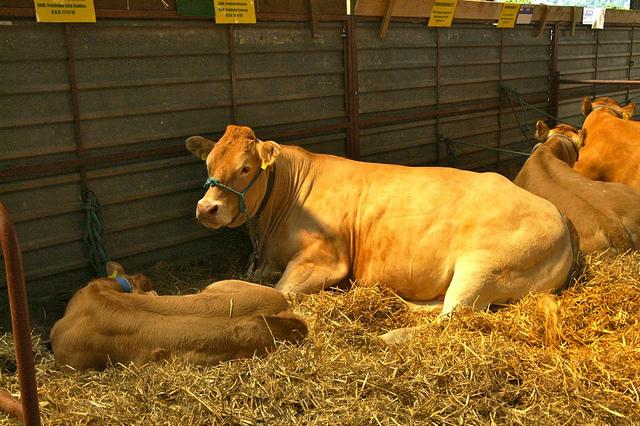What color is the handle tied around the sunlit cow's face?

Choices:
A) blue
B) green
C) red
D) yellow green 